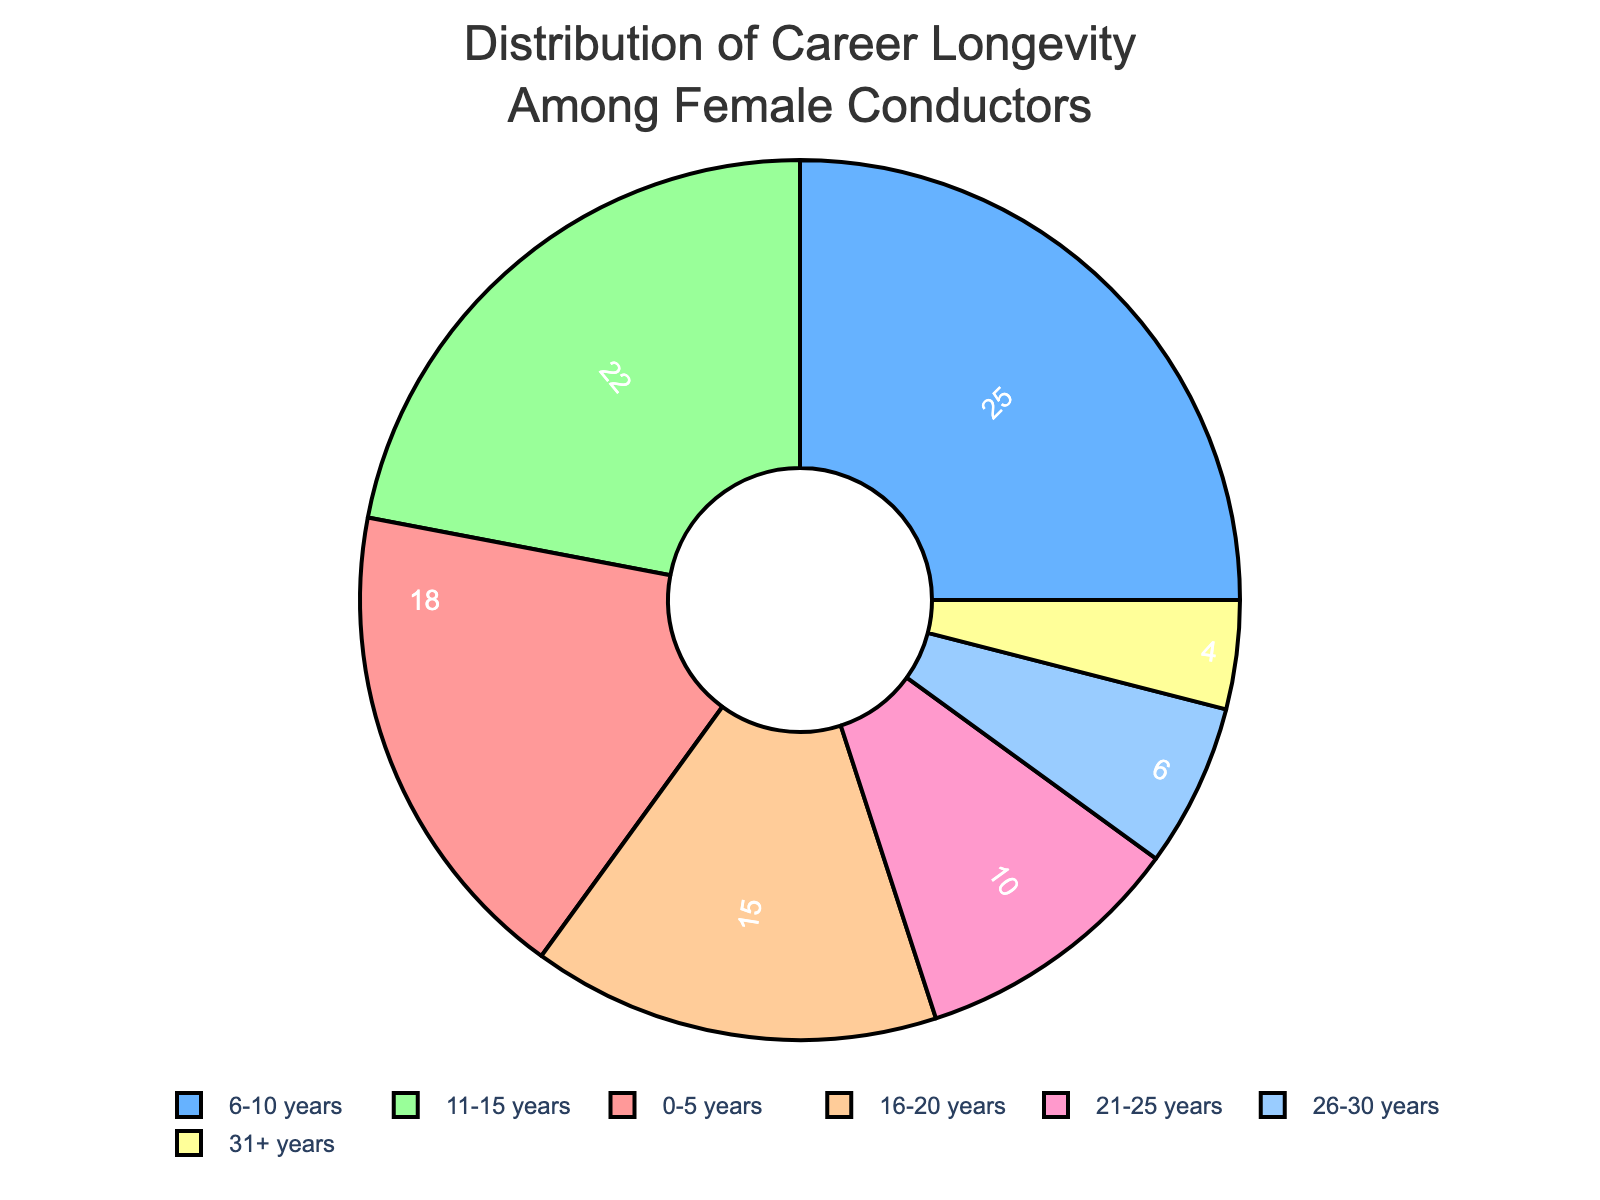Which experience category has the highest percentage? The figure shows the percentage distribution for each experience category. The category "6-10 years" has the highest percentage value shown in the chart.
Answer: 6-10 years What is the total percentage of female conductors with 11 or more years of experience? To find this, sum the percentages of all categories with 11 or more years of experience: 22% (11-15 years) + 15% (16-20 years) + 10% (21-25 years) + 6% (26-30 years) + 4% (31+ years). This gives a total of 57%.
Answer: 57% What percentage of female conductors have less than 11 years of experience? Add the percentages for the "0-5 years" and "6-10 years" categories: 18% + 25% = 43%.
Answer: 43% Which experience category has the smallest segment in the pie chart? From the visual information in the pie chart, the segment for "31+ years" is the smallest by percentage.
Answer: 31+ years How much larger is the "6-10 years" segment compared to the "26-30 years" segment? Subtract the percentage of the "26-30 years" segment from the "6-10 years" segment: 25% - 6% = 19%.
Answer: 19% What's the combined percentage of female conductors with 0-5 years and 11-15 years of experience? Add the percentages for "0-5 years" and "11-15 years": 18% + 22% = 40%.
Answer: 40% Is the percentage of female conductors with 16-20 years of experience greater than those with 26-30 years? Compare the percentages given: 15% (16-20 years) is greater than 6% (26-30 years).
Answer: Yes What is the difference in percentage between the 21-25 years and the 31+ years categories? Subtract the percentage of the "31+ years" category from the "21-25 years" category: 10% - 4% = 6%.
Answer: 6% How does the percentage for each experience category visually compare by color? The pie chart uses different colors for each category: #FF9999 (0-5 years), #66B2FF (6-10 years), #99FF99 (11-15 years), #FFCC99 (16-20 years), #FF99CC (21-25 years), #99CCFF (26-30 years), and #FFFF99 (31+ years). The size of the segment coupled with its color helps visually compare the percentages.
Answer: Colors differentiate experience categories What is the total percentage of female conductors with 16 or more years of experience? Sum the percentages of categories with 16 or more years of experience: 15% (16-20 years) + 10% (21-25 years) + 6% (26-30 years) + 4% (31+ years) = 35%.
Answer: 35% 